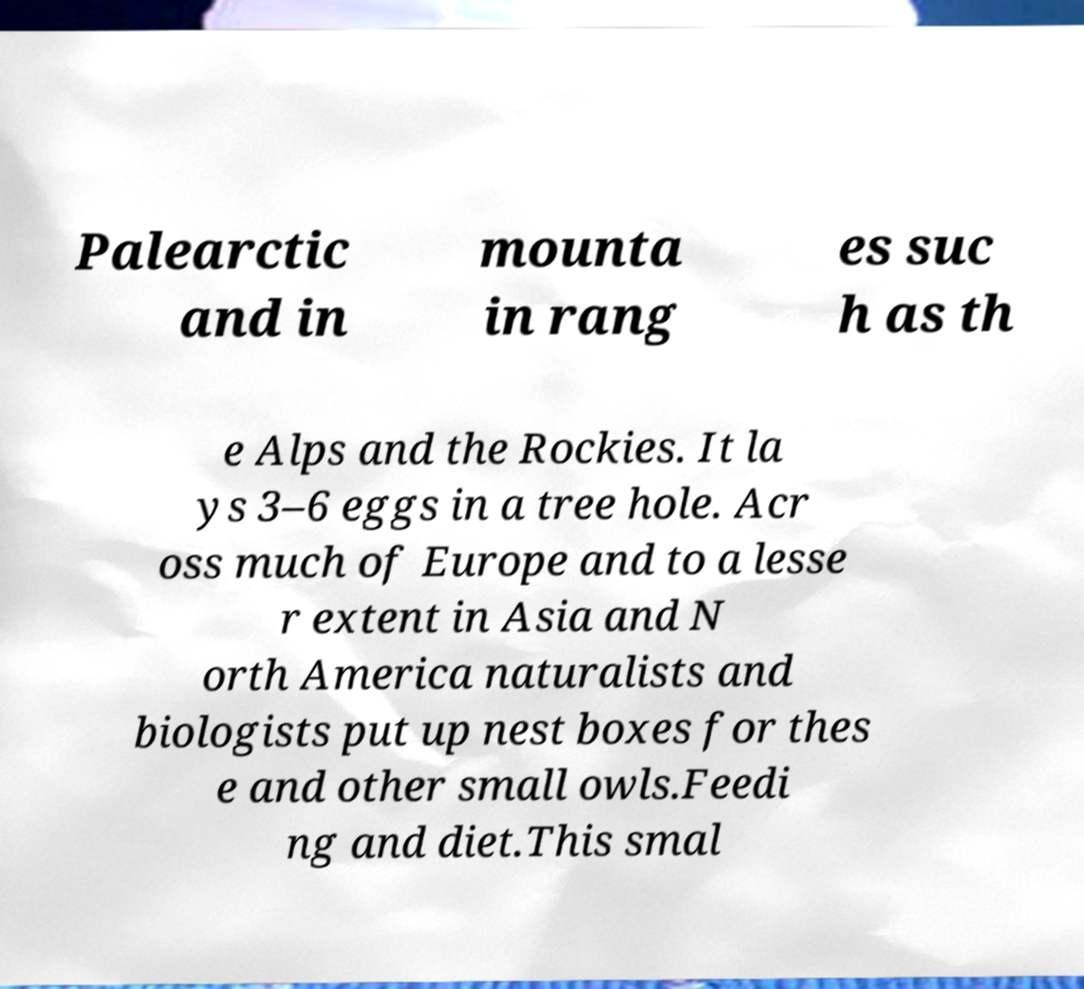I need the written content from this picture converted into text. Can you do that? Palearctic and in mounta in rang es suc h as th e Alps and the Rockies. It la ys 3–6 eggs in a tree hole. Acr oss much of Europe and to a lesse r extent in Asia and N orth America naturalists and biologists put up nest boxes for thes e and other small owls.Feedi ng and diet.This smal 